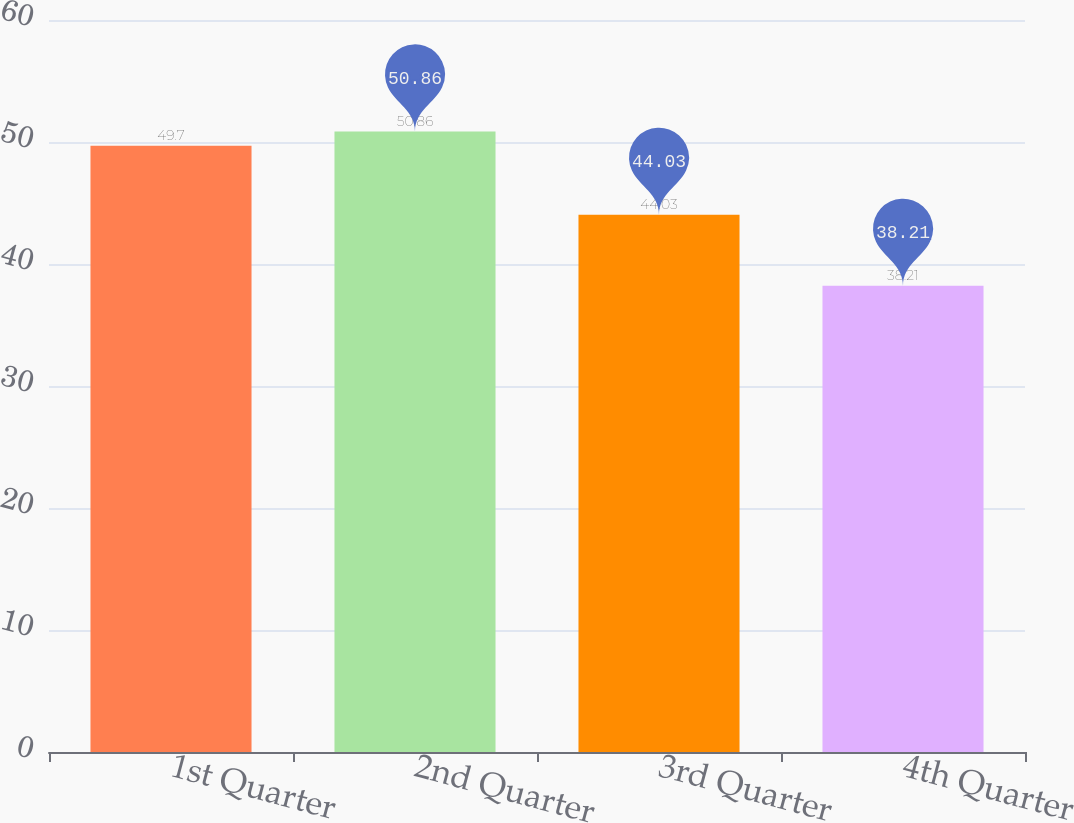Convert chart. <chart><loc_0><loc_0><loc_500><loc_500><bar_chart><fcel>1st Quarter<fcel>2nd Quarter<fcel>3rd Quarter<fcel>4th Quarter<nl><fcel>49.7<fcel>50.86<fcel>44.03<fcel>38.21<nl></chart> 